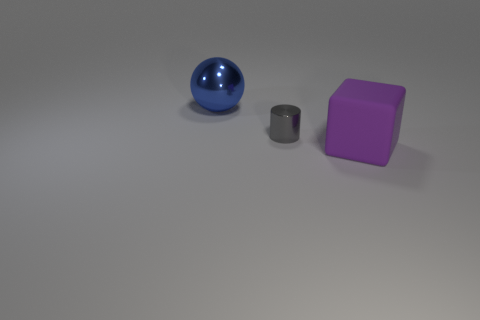Is the surface on which the objects are placed horizontal or at an angle? The surface where the objects are placed appears to be horizontal, as indicated by the even positioning of the objects and the uniform distribution of shadows. 